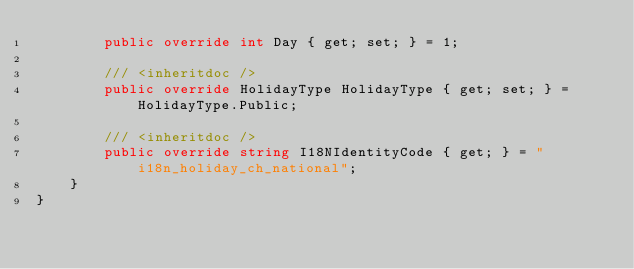Convert code to text. <code><loc_0><loc_0><loc_500><loc_500><_C#_>        public override int Day { get; set; } = 1;

        /// <inheritdoc />
        public override HolidayType HolidayType { get; set; } = HolidayType.Public;

        /// <inheritdoc />
        public override string I18NIdentityCode { get; } = "i18n_holiday_ch_national";
    }
}</code> 